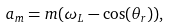<formula> <loc_0><loc_0><loc_500><loc_500>a _ { m } = m ( \omega _ { L } - \cos ( \theta _ { r } ) ) ,</formula> 